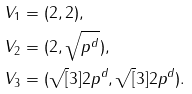Convert formula to latex. <formula><loc_0><loc_0><loc_500><loc_500>V _ { 1 } & = ( 2 , 2 ) , \\ V _ { 2 } & = ( 2 , \sqrt { p ^ { d } } ) , \\ V _ { 3 } & = ( \sqrt { [ } 3 ] { 2 p ^ { d } } , \sqrt { [ } 3 ] { 2 p ^ { d } } ) .</formula> 